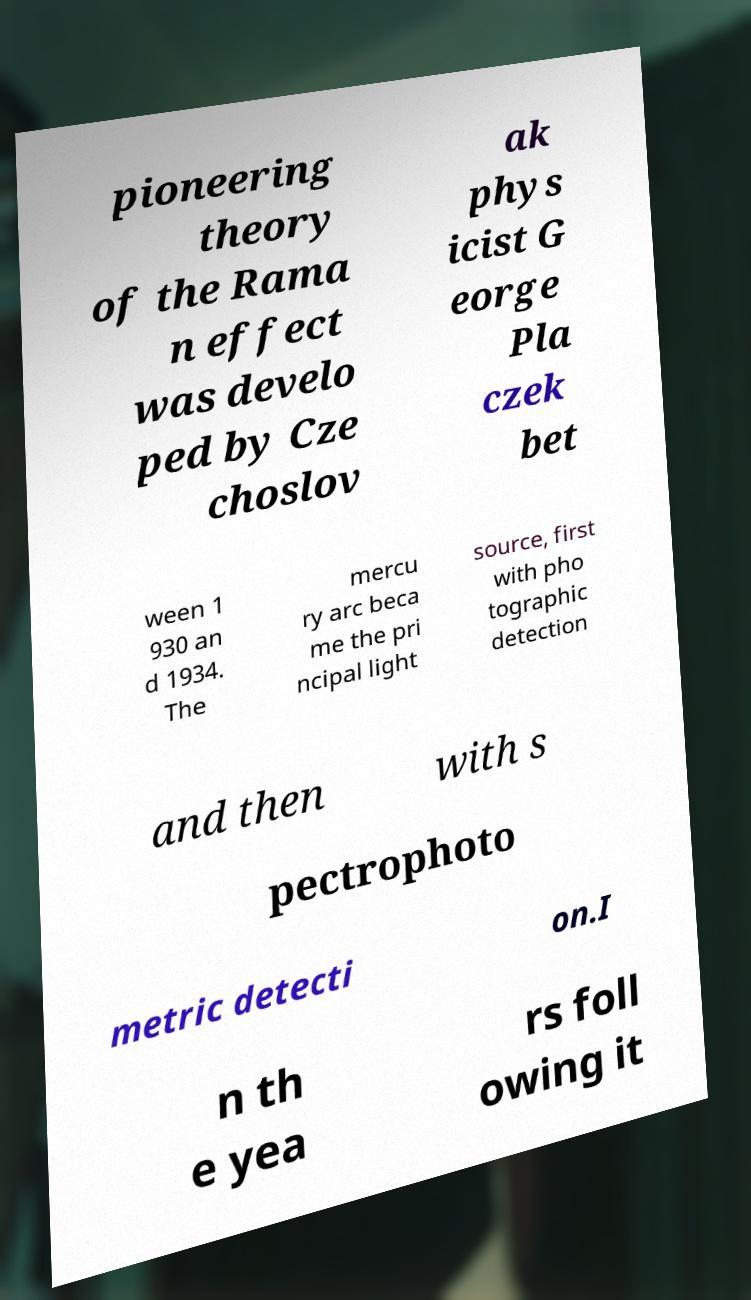Can you read and provide the text displayed in the image?This photo seems to have some interesting text. Can you extract and type it out for me? pioneering theory of the Rama n effect was develo ped by Cze choslov ak phys icist G eorge Pla czek bet ween 1 930 an d 1934. The mercu ry arc beca me the pri ncipal light source, first with pho tographic detection and then with s pectrophoto metric detecti on.I n th e yea rs foll owing it 